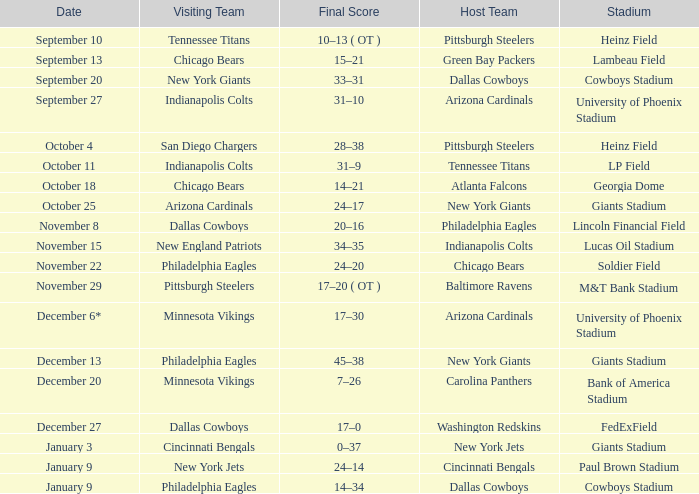Tell me the date for pittsburgh steelers November 29. 